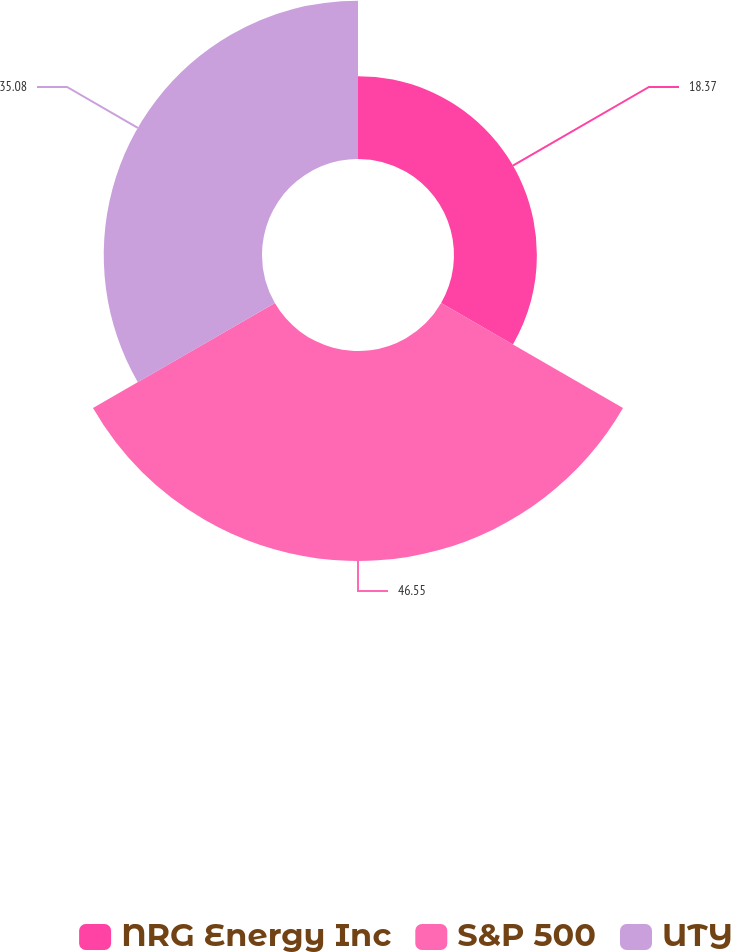Convert chart to OTSL. <chart><loc_0><loc_0><loc_500><loc_500><pie_chart><fcel>NRG Energy Inc<fcel>S&P 500<fcel>UTY<nl><fcel>18.37%<fcel>46.55%<fcel>35.08%<nl></chart> 